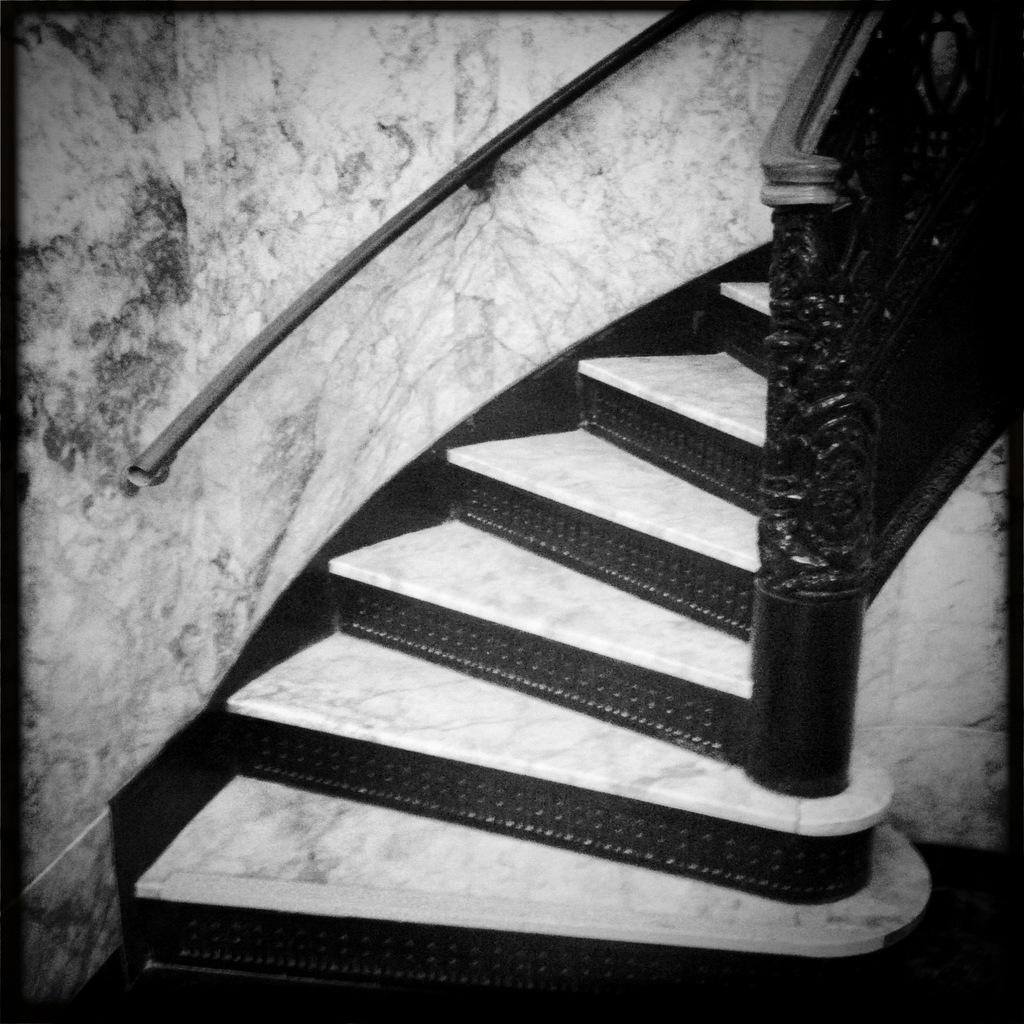Can you describe this image briefly? In this picture we can observe and a black color railing. We can observe marbles on the steps. This is a black and white image. 